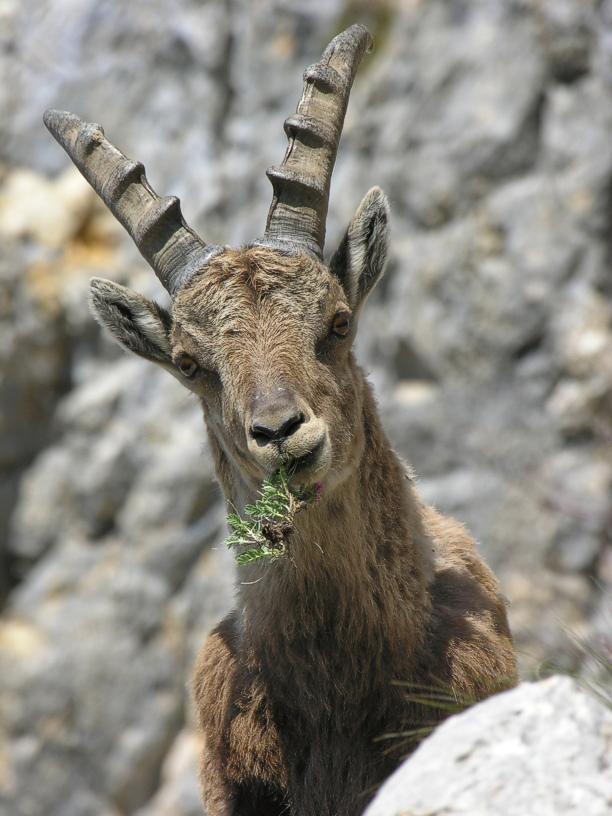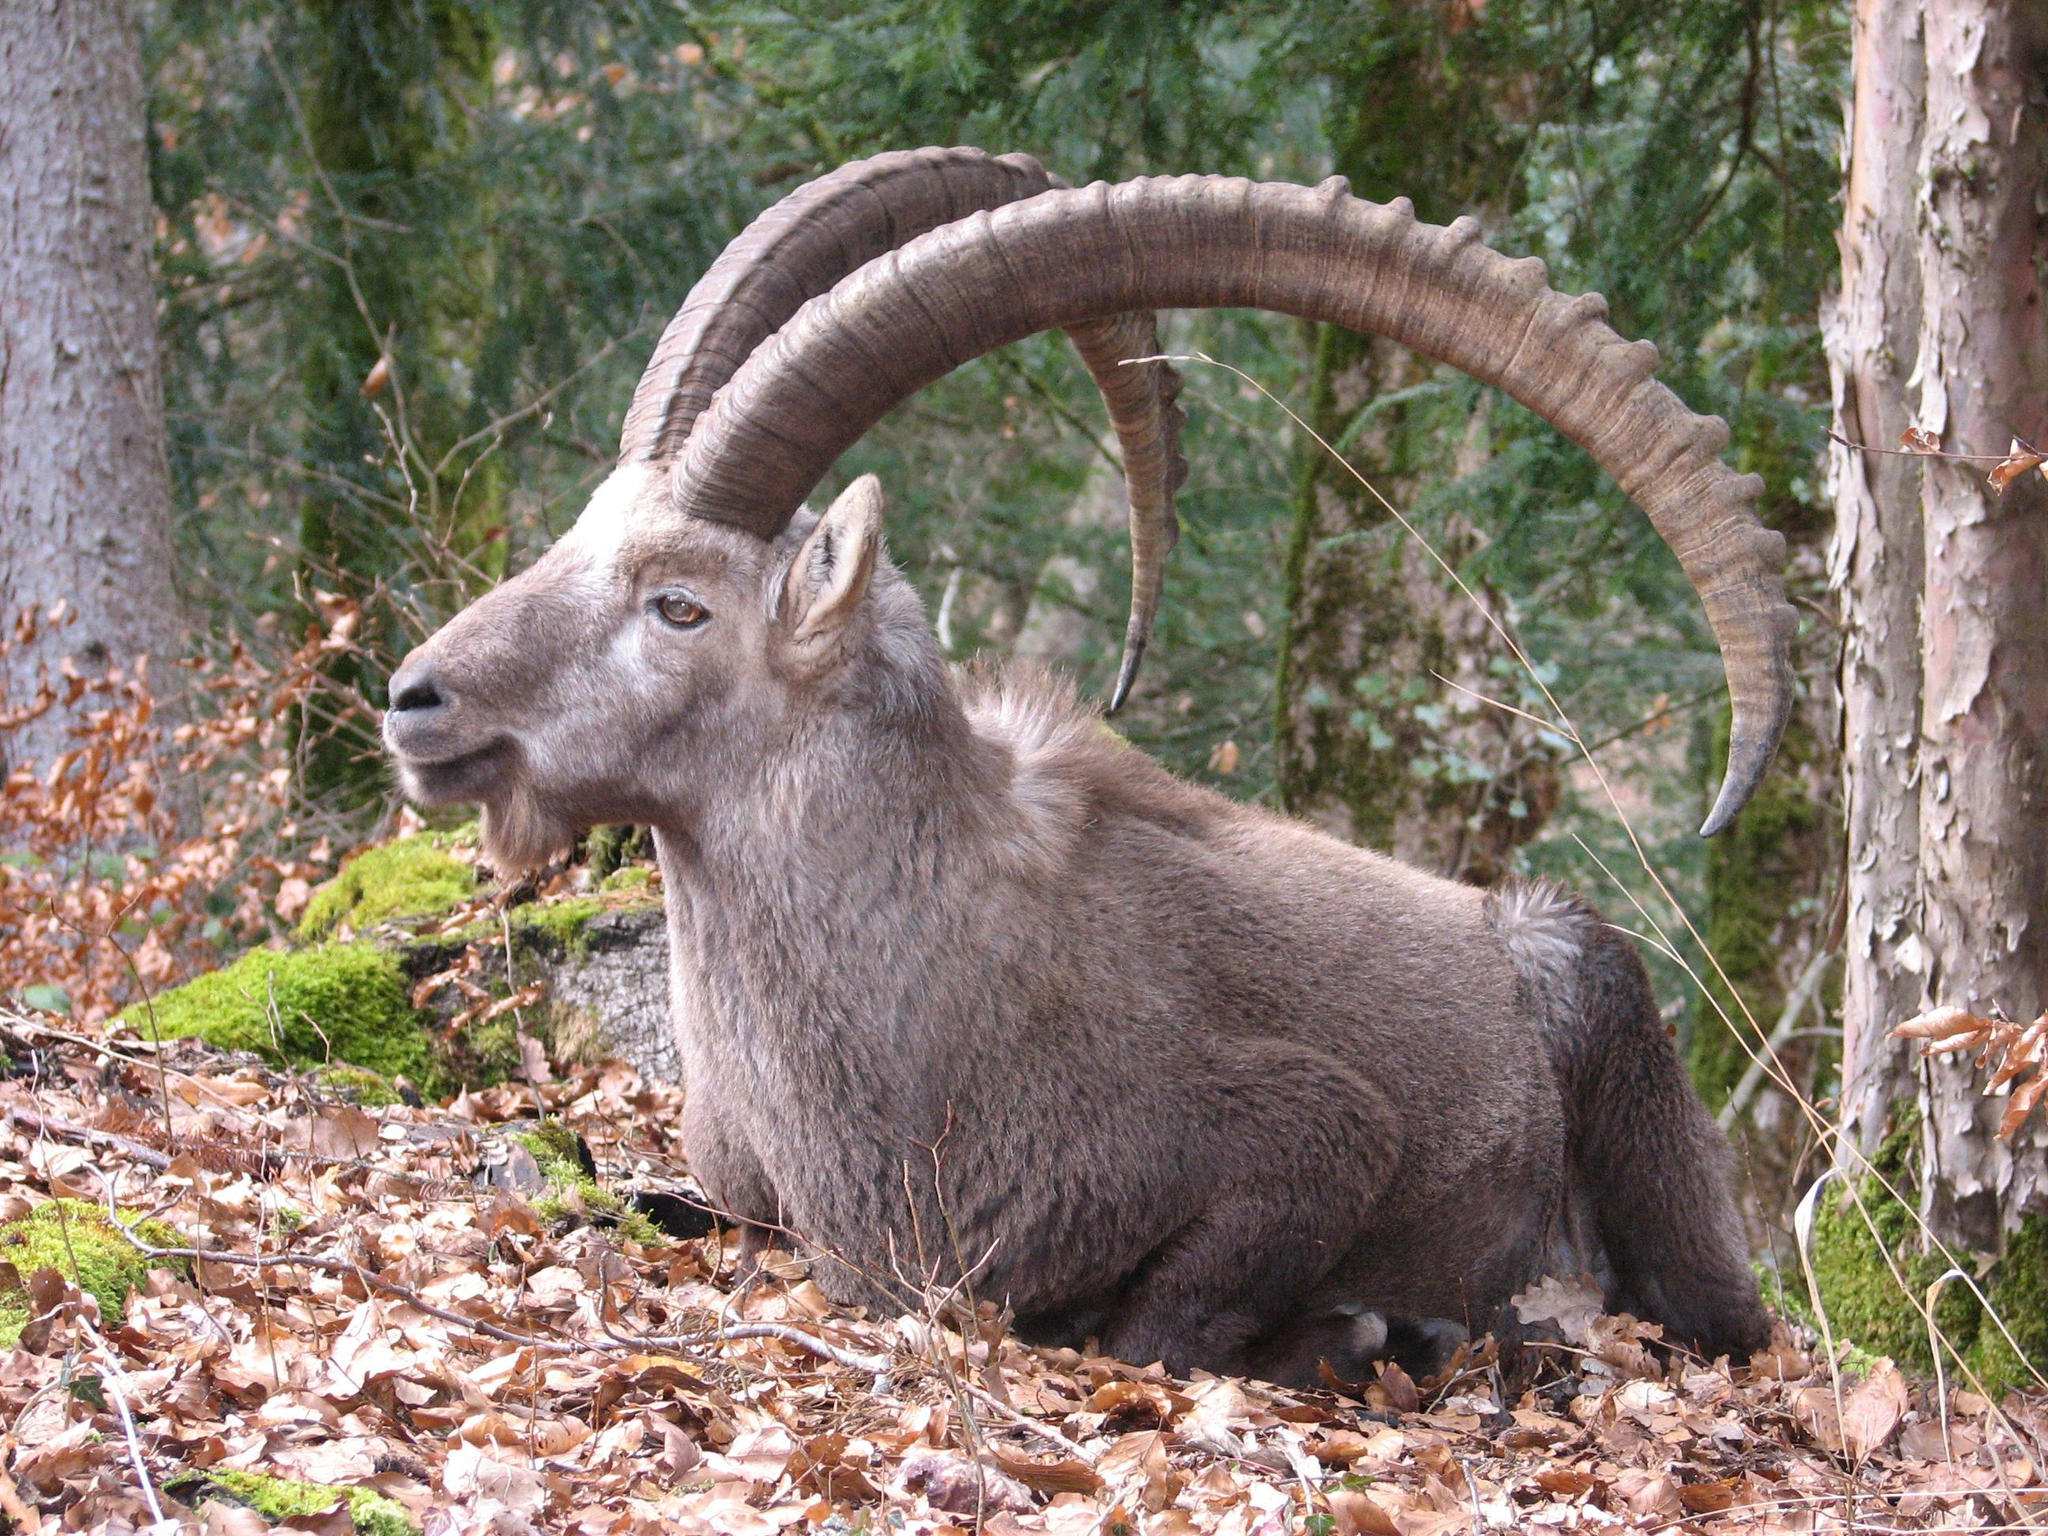The first image is the image on the left, the second image is the image on the right. For the images shown, is this caption "In the left image, one horned animal looks directly at the camera." true? Answer yes or no. Yes. The first image is the image on the left, the second image is the image on the right. Evaluate the accuracy of this statement regarding the images: "In one image, at least one horned animal is lying down with its legs tucked under it.". Is it true? Answer yes or no. Yes. 